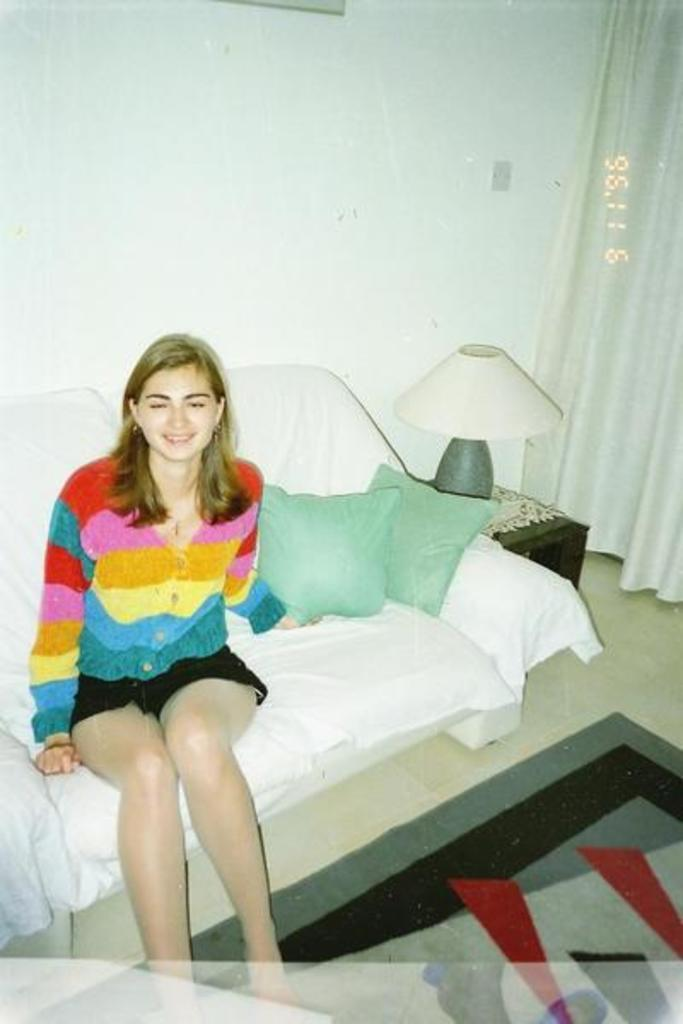What is the color of the wall in the image? The wall in the image is white. What type of window treatment is present in the image? There is a curtain in the image. What type of lighting is present in the image? There is a lamp in the image. What is the woman in the image doing? The woman is sitting on a sofa in the image. How many fifths are present in the image? There is no mention of "fifths" in the image, so it cannot be determined. What is the chance of the woman standing up in the image? The image does not provide any information about the likelihood of the woman standing up, so it cannot be determined. 